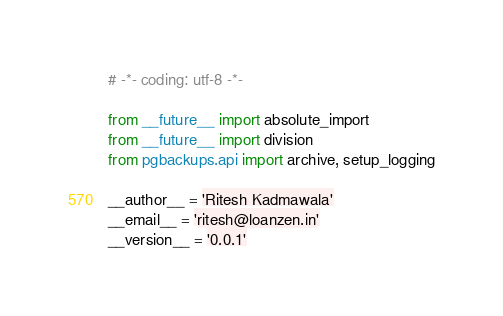<code> <loc_0><loc_0><loc_500><loc_500><_Python_># -*- coding: utf-8 -*-

from __future__ import absolute_import
from __future__ import division
from pgbackups.api import archive, setup_logging

__author__ = 'Ritesh Kadmawala'
__email__ = 'ritesh@loanzen.in'
__version__ = '0.0.1'



</code> 